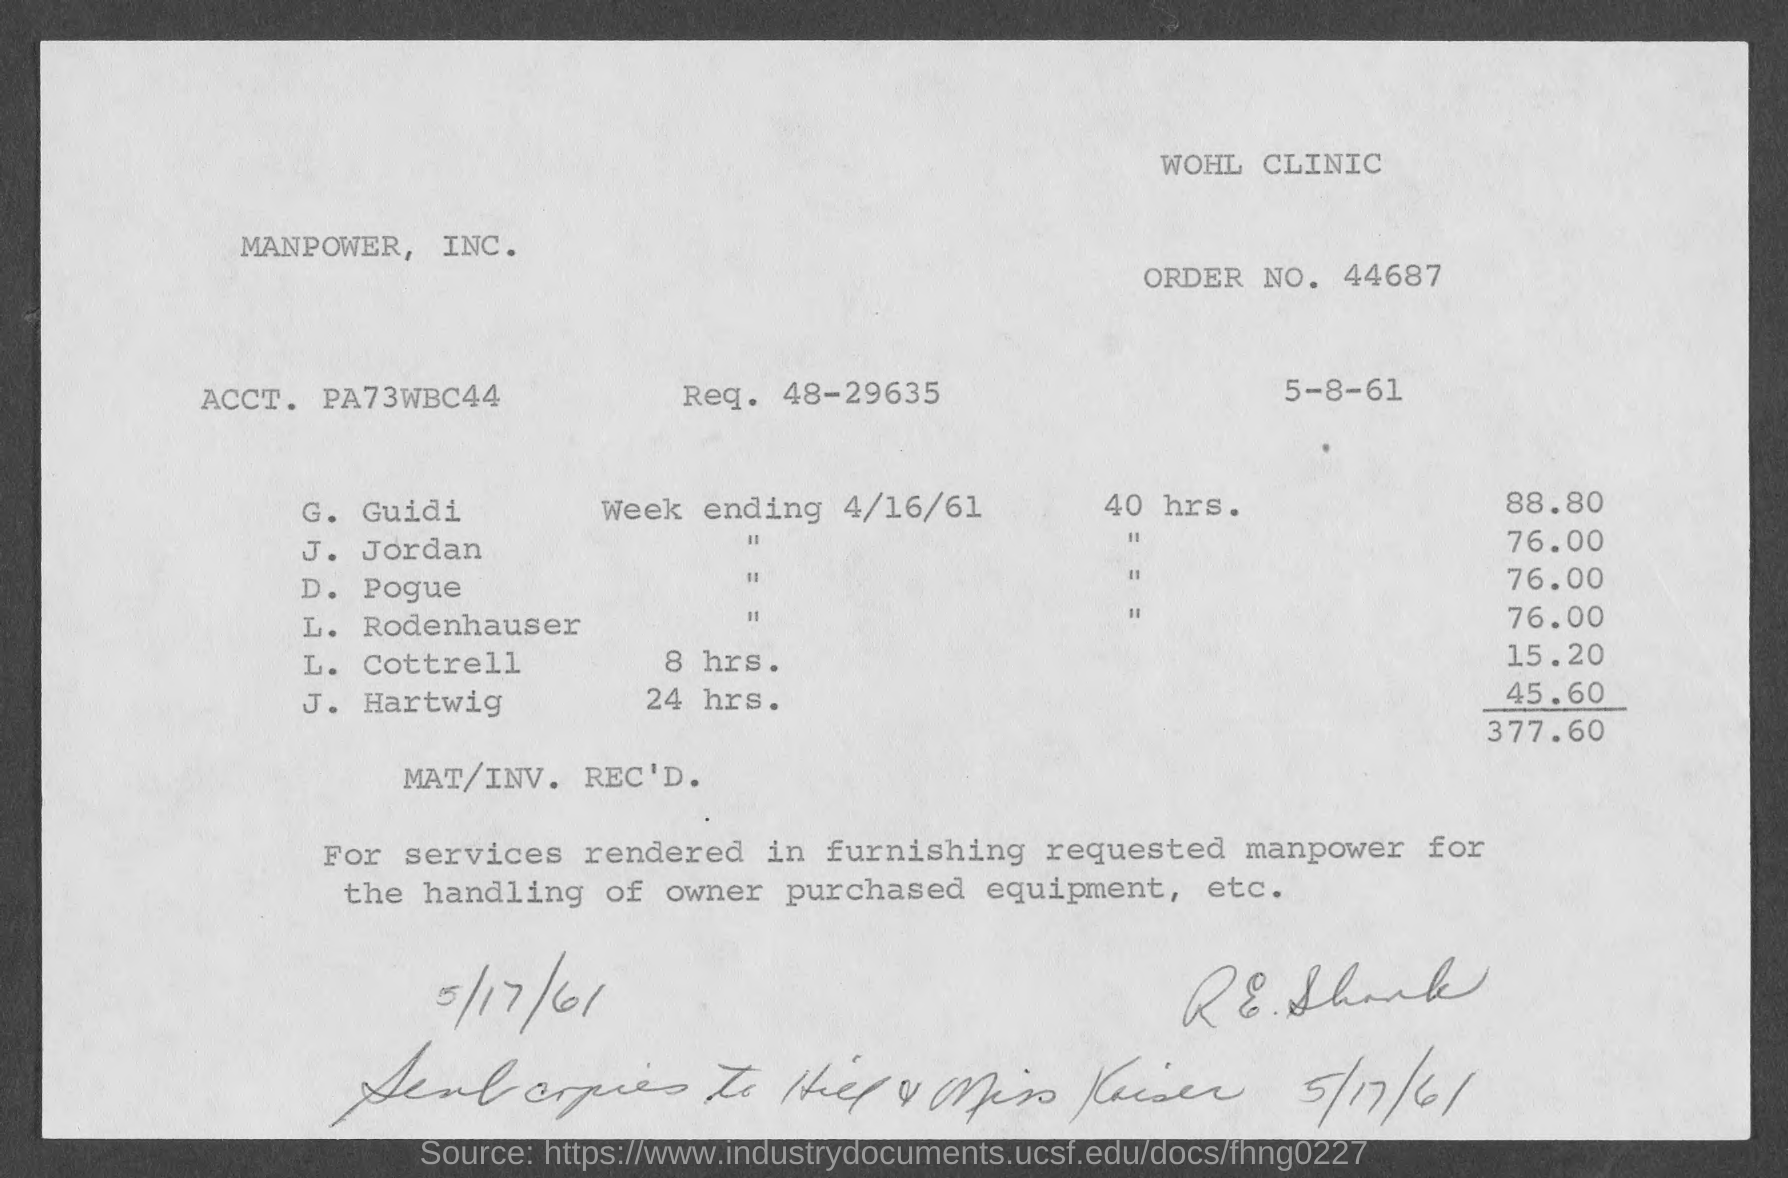What is the Req. No. given in the invoice?
Provide a short and direct response. 48-29635. What is the issued date of the invoice?
Give a very brief answer. 5-8-61. What is the Order No. given in the invoice?
Ensure brevity in your answer.  44687. What is the total invoice amount as per the document?
Give a very brief answer. 377.60. 